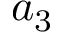Convert formula to latex. <formula><loc_0><loc_0><loc_500><loc_500>a _ { 3 }</formula> 